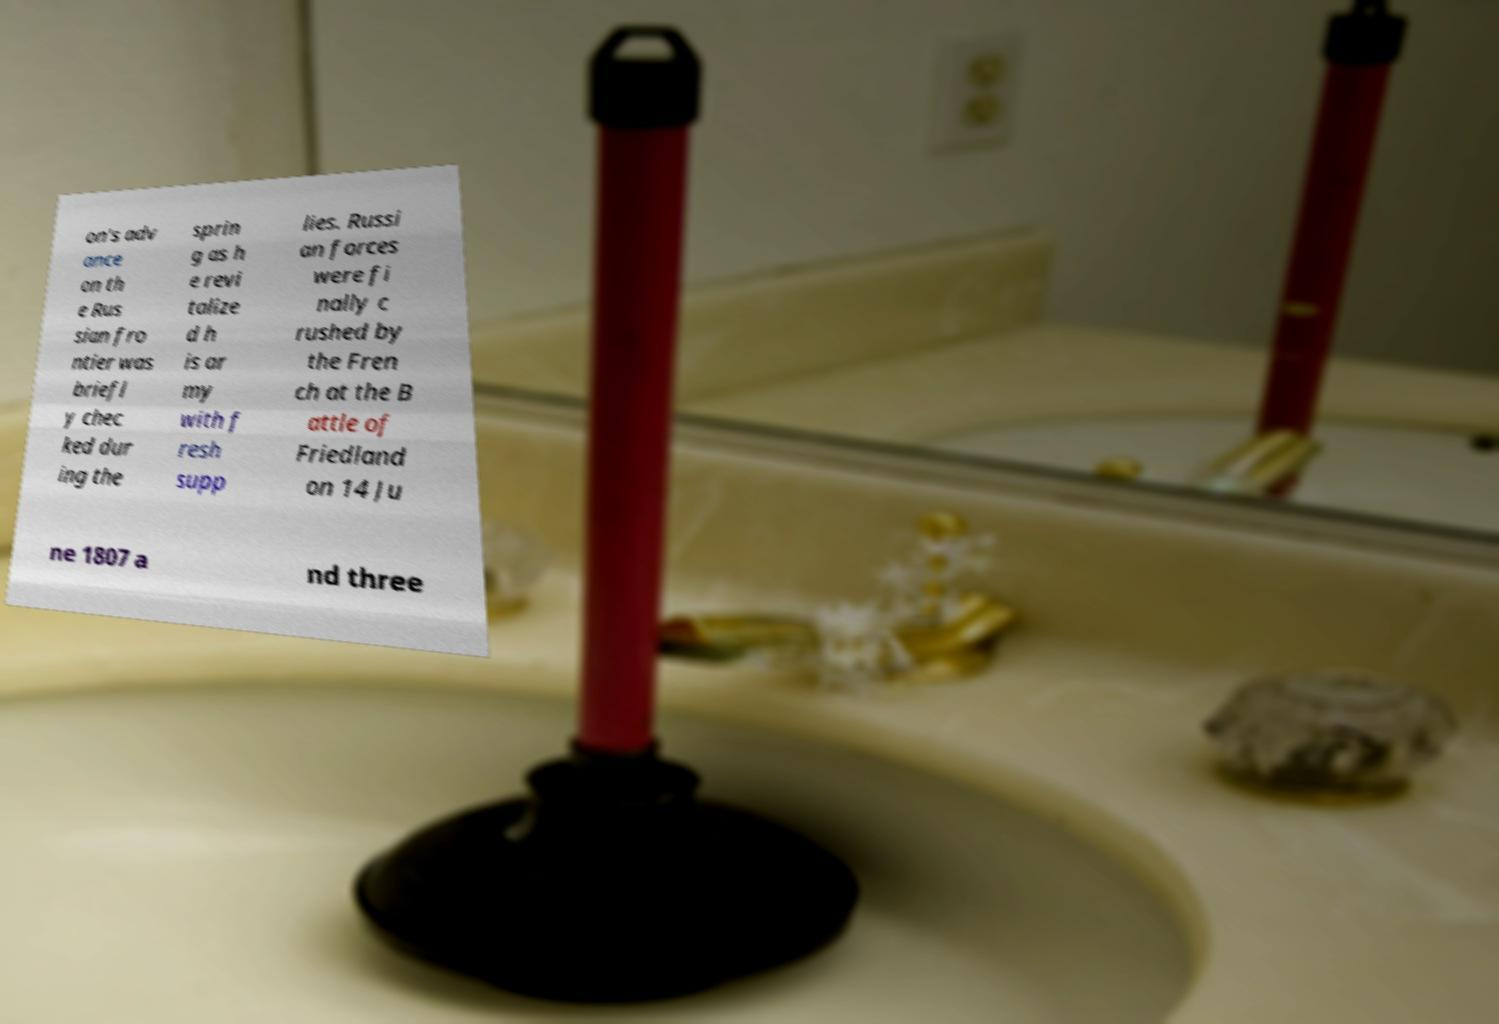I need the written content from this picture converted into text. Can you do that? on's adv ance on th e Rus sian fro ntier was briefl y chec ked dur ing the sprin g as h e revi talize d h is ar my with f resh supp lies. Russi an forces were fi nally c rushed by the Fren ch at the B attle of Friedland on 14 Ju ne 1807 a nd three 